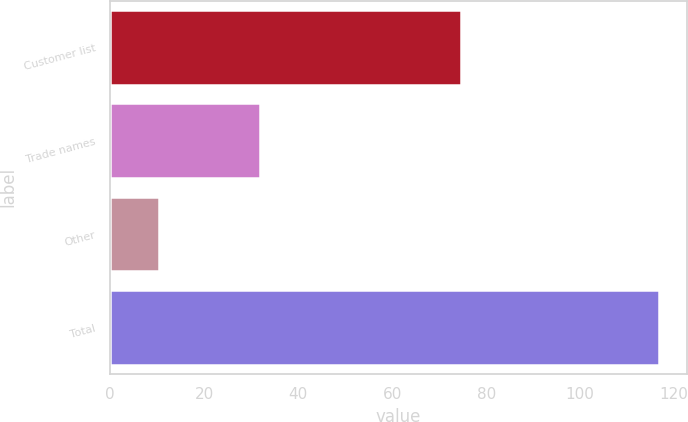<chart> <loc_0><loc_0><loc_500><loc_500><bar_chart><fcel>Customer list<fcel>Trade names<fcel>Other<fcel>Total<nl><fcel>74.6<fcel>31.8<fcel>10.4<fcel>116.8<nl></chart> 